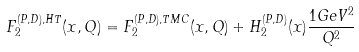<formula> <loc_0><loc_0><loc_500><loc_500>F _ { 2 } ^ { ( P , D ) , H T } ( x , Q ) = F _ { 2 } ^ { ( P , D ) , T M C } ( x , Q ) + H _ { 2 } ^ { ( P , D ) } ( x ) \frac { 1 G e V ^ { 2 } } { Q ^ { 2 } }</formula> 